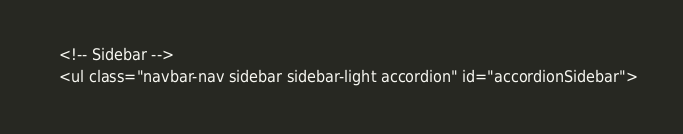<code> <loc_0><loc_0><loc_500><loc_500><_PHP_>   <!-- Sidebar -->
   <ul class="navbar-nav sidebar sidebar-light accordion" id="accordionSidebar"></code> 